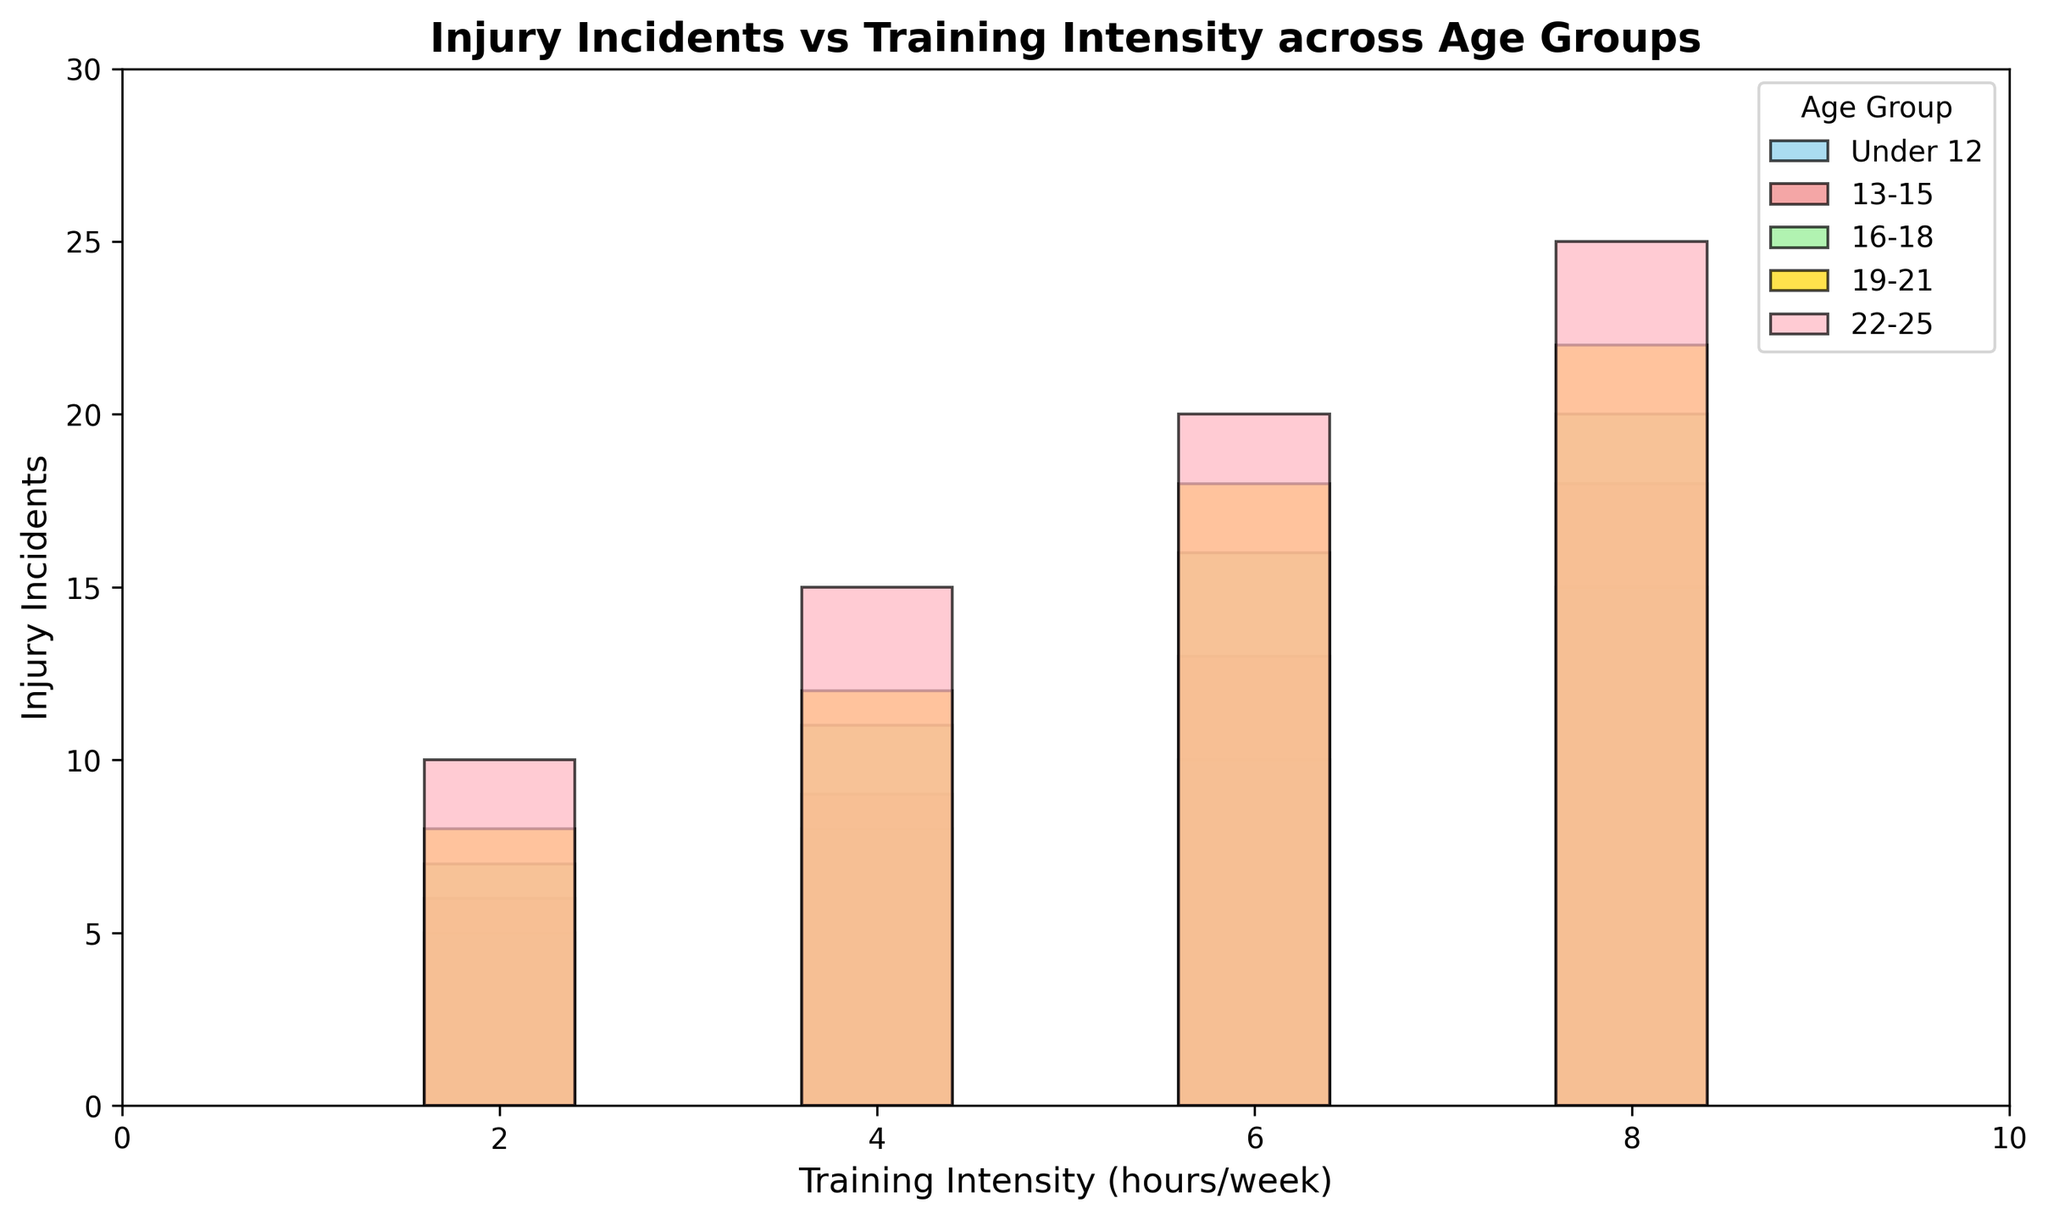哪個年齡組別在訓練強度8小時/週時受傷事件最多？ 從圖表中觀察可以發現，在訓練強度8小時/週，22-25歲這個年齡組別的受傷事件數量最高。該組別的柱狀圖高度最大，代表這個組別的受傷事件數達到25起。
Answer: 22-25歲 在所有訓練強度下, 哪個年齡組別的受傷事件最少? 檢查所有訓練強度下各個年齡組別的柱狀圖，可以發現Under 12這個年齡組別在訓練強度2小時/週時受傷事件數量最少，為5起。
Answer: Under 12 19-21歲年齡組別中，受傷事件數的增幅在訓練強度4小時/週和6小時/週之間是多少？ 根據圖表，可以發現19-21歲年齡組別在訓練強度4小時/週的受傷事件數為12起，在6小時/週的受傷事件數為18起。這之間的增幅為18 - 12 = 6起。
Answer: 6起 Under 12和16-18兩個年齡組別在訓練強度6小時/週時的受傷事件總和是多少？ 從圖表中可見，Under 12在訓練強度6小時/週的受傷事件數為10起，16-18在訓練強度6小時/週的受傷事件數為16起。兩者的總和為10 + 16 = 26起。
Answer: 26起 16-18歲年齡組別在訓練強度8小時/週的受傷事件數比訓練強度2小時/週多多少？ 從圖表可以看出, 16-18歲年齡組別在訓練強度8小時/週的受傷事件數為20起，而在訓練強度2小時/週的受傷事件數為7起，差異為20 - 7 = 13起。
Answer: 13起 哪個年齡組別的柱狀圖通常是綠色的？ 圖表中，16-18歲年齡組別的柱狀圖通常是綠色的，因為設計中使用了這種顏色來表示這個年齡組別。
Answer: 16-18歲 16-18年齡組別在訓練強度4小時/週和8小時/週的受傷事件數的平均值是多少？ 圖表顯示，16-18歲年齡組別在訓練強度4小時/週的受傷事件數為11起，而在訓練強度8小時/週的受傷事件數為20起。其平均值計算為(11 + 20) / 2 = 15.5起。
Answer: 15.5起 不同年齡組別在訓練強度2小時/週時的受傷事件數目是否相同？ 從圖表可以看到，不同年齡組別在訓練強度2小時/週的受傷事件數目不相同。Under 12為5起，13-15為6起，16-18為7起，19-21為8起，22-25則為10起。
Answer: 不相同 